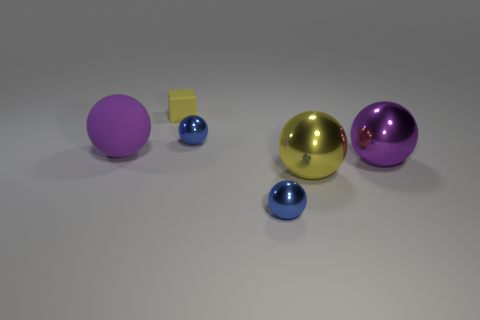Is there anything else that is made of the same material as the yellow sphere?
Ensure brevity in your answer.  Yes. There is a matte object that is to the left of the yellow matte cube; is its color the same as the large object right of the large yellow object?
Your answer should be very brief. Yes. Are there any other things that are the same color as the large rubber thing?
Make the answer very short. Yes. There is a big metal sphere on the left side of the purple metallic object; does it have the same color as the matte cube?
Provide a short and direct response. Yes. Is the size of the purple rubber sphere the same as the yellow thing that is in front of the small cube?
Give a very brief answer. Yes. Are there any balls that have the same size as the yellow block?
Offer a terse response. Yes. What number of other objects are the same material as the small yellow block?
Offer a terse response. 1. There is a tiny object that is both behind the yellow sphere and in front of the yellow matte block; what color is it?
Keep it short and to the point. Blue. Are the big purple ball on the right side of the yellow cube and the yellow object that is on the right side of the tiny matte thing made of the same material?
Ensure brevity in your answer.  Yes. Do the blue ball that is in front of the yellow ball and the tiny yellow object have the same size?
Offer a very short reply. Yes. 